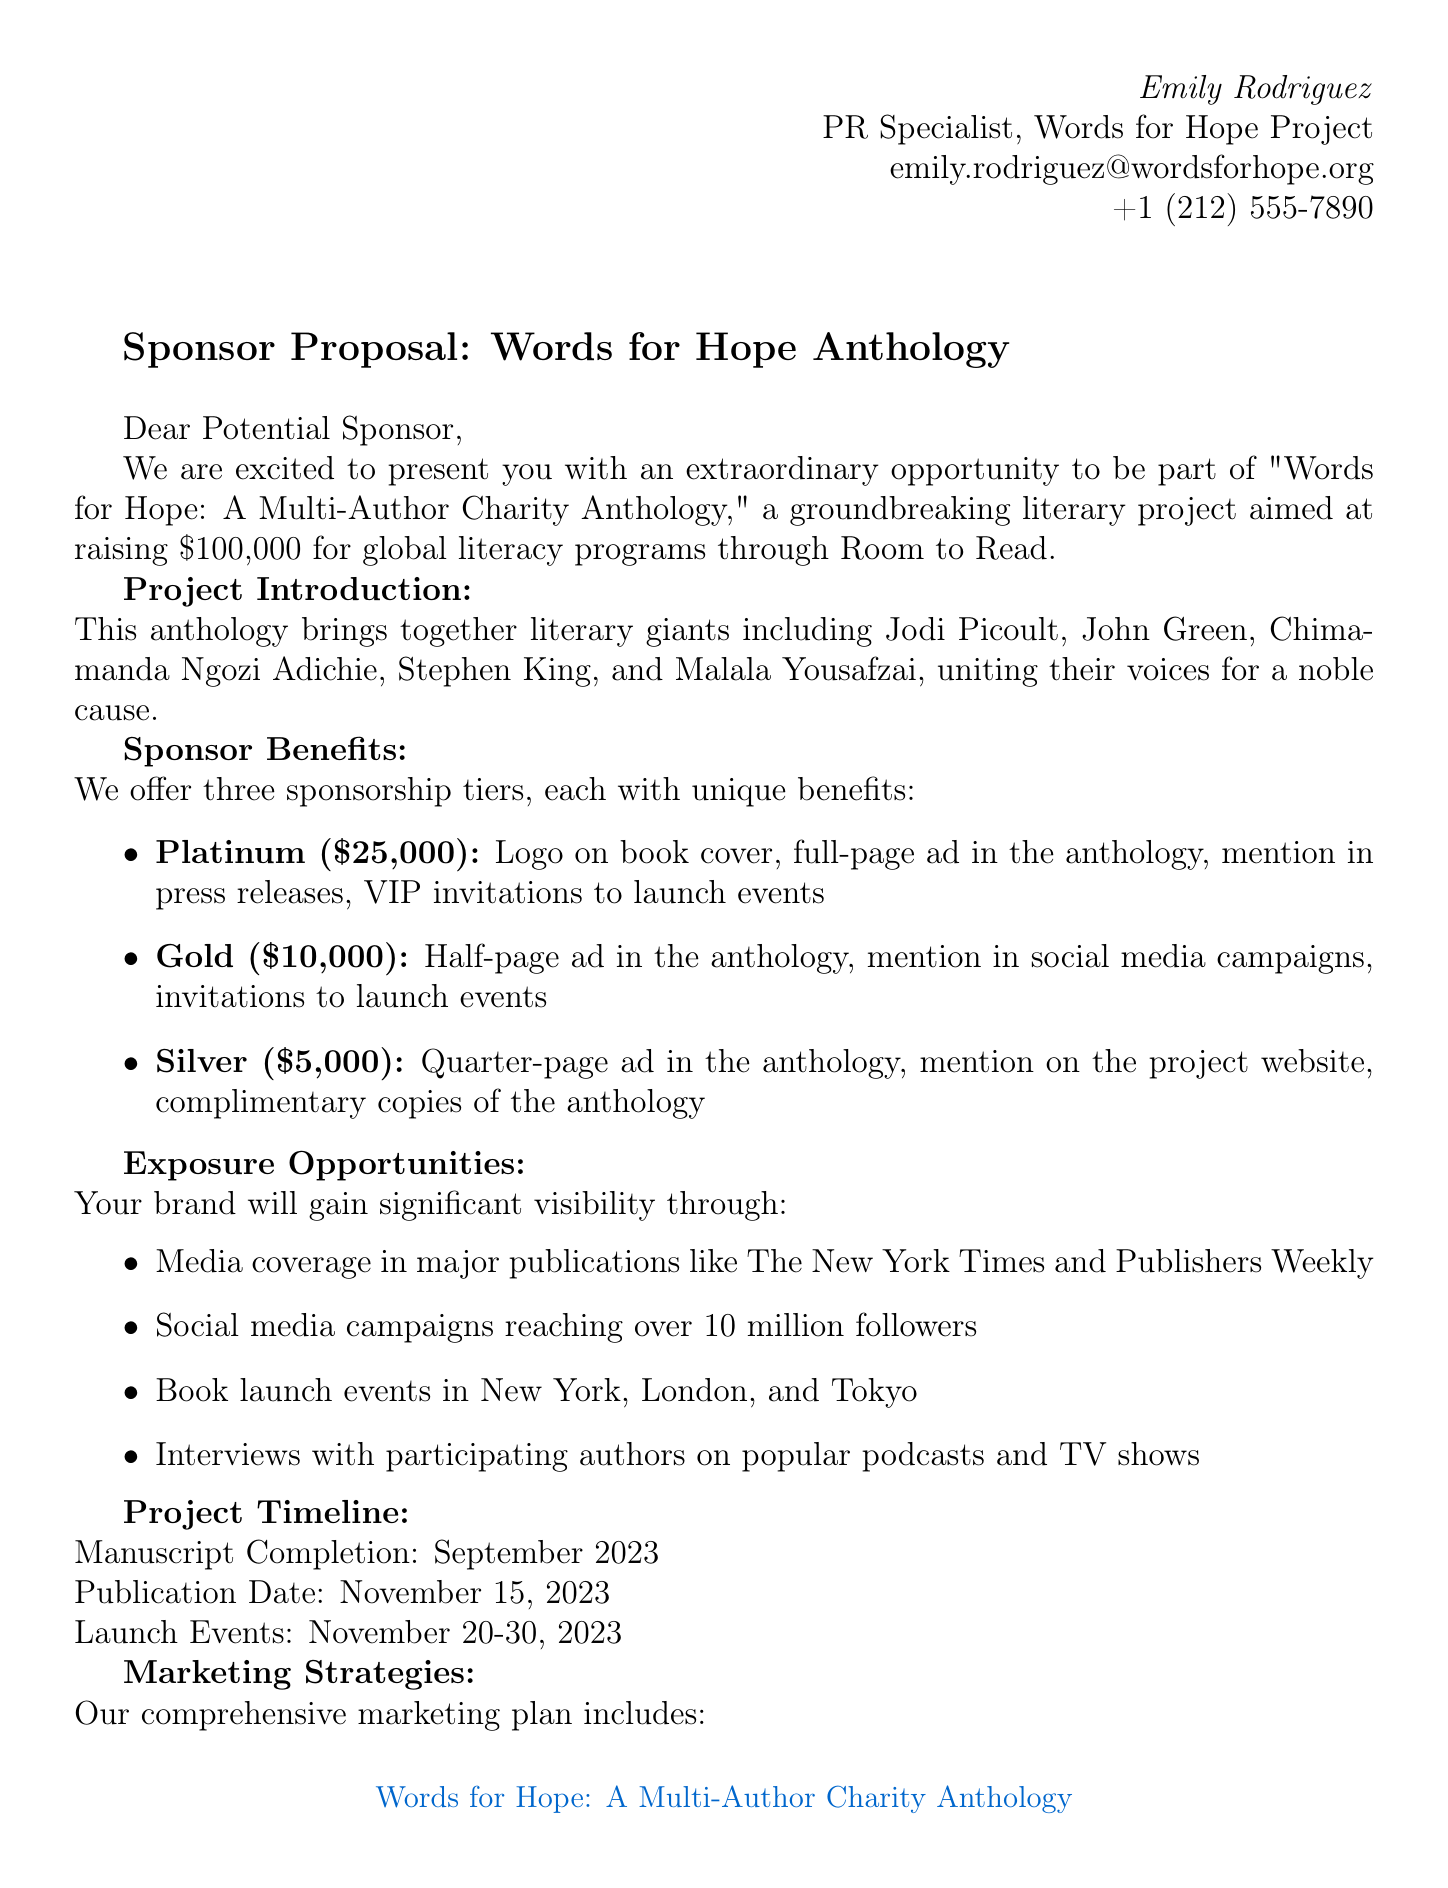What is the name of the charity beneficiary? The document states that the charity beneficiary of the project is Room to Read.
Answer: Room to Read What is the project goal? The letter outlines the project's goal as raising $100,000 for global literacy programs.
Answer: $100,000 Who are two of the participating authors? The document mentions several authors, including Jodi Picoult and John Green, as participating in the anthology.
Answer: Jodi Picoult, John Green What is the Platinum sponsorship amount? The letter specifies that the Platinum sponsorship tier is set at $25,000.
Answer: $25,000 When is the publication date of the anthology? The publication date for the anthology is given in the document as November 15, 2023.
Answer: November 15, 2023 What is one benefit of the Gold sponsorship tier? The document lists a half-page ad in the anthology as one of the benefits for the Gold sponsorship tier.
Answer: Half-page ad in the anthology Which major publications will cover the project? The letter notes that there will be media coverage in major publications like The New York Times and Publishers Weekly.
Answer: The New York Times, Publishers Weekly What are the dates for the launch events? The letter specifies that the launch events will take place from November 20-30, 2023.
Answer: November 20-30, 2023 What is one marketing strategy mentioned in the document? The document discusses several marketing strategies, including influencer partnerships with BookTok creators.
Answer: Influencer partnerships with BookTok creators 